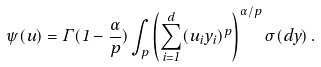<formula> <loc_0><loc_0><loc_500><loc_500>\psi ( u ) = \Gamma ( 1 - \frac { \alpha } { p } ) \int _ { p } \left ( \sum _ { i = 1 } ^ { d } ( u _ { i } y _ { i } ) ^ { p } \right ) ^ { \alpha / p } \sigma ( d y ) \, .</formula> 